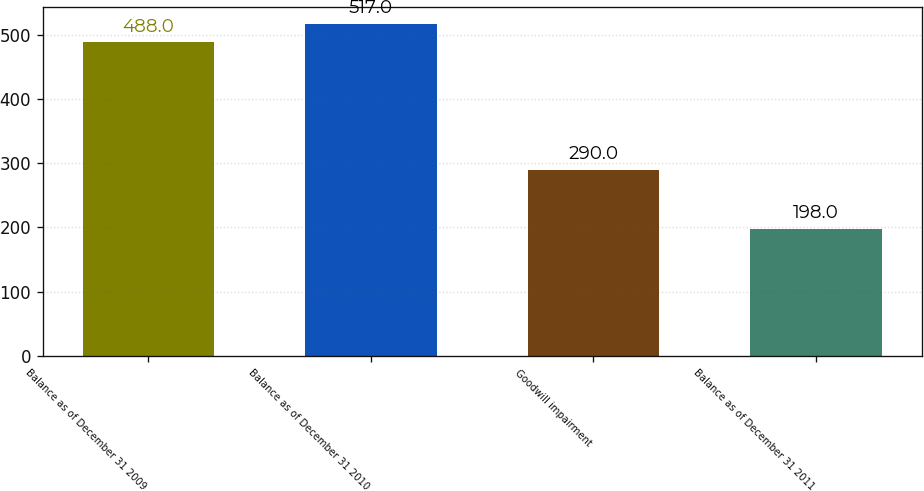Convert chart. <chart><loc_0><loc_0><loc_500><loc_500><bar_chart><fcel>Balance as of December 31 2009<fcel>Balance as of December 31 2010<fcel>Goodwill impairment<fcel>Balance as of December 31 2011<nl><fcel>488<fcel>517<fcel>290<fcel>198<nl></chart> 